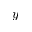<formula> <loc_0><loc_0><loc_500><loc_500>y</formula> 